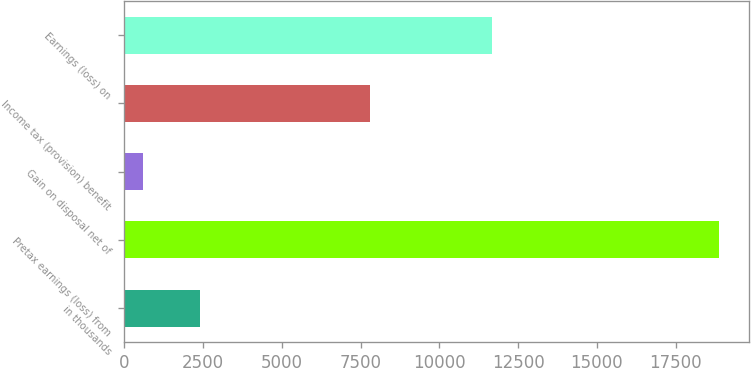<chart> <loc_0><loc_0><loc_500><loc_500><bar_chart><fcel>in thousands<fcel>Pretax earnings (loss) from<fcel>Gain on disposal net of<fcel>Income tax (provision) benefit<fcel>Earnings (loss) on<nl><fcel>2412.8<fcel>18872<fcel>584<fcel>7790<fcel>11666<nl></chart> 